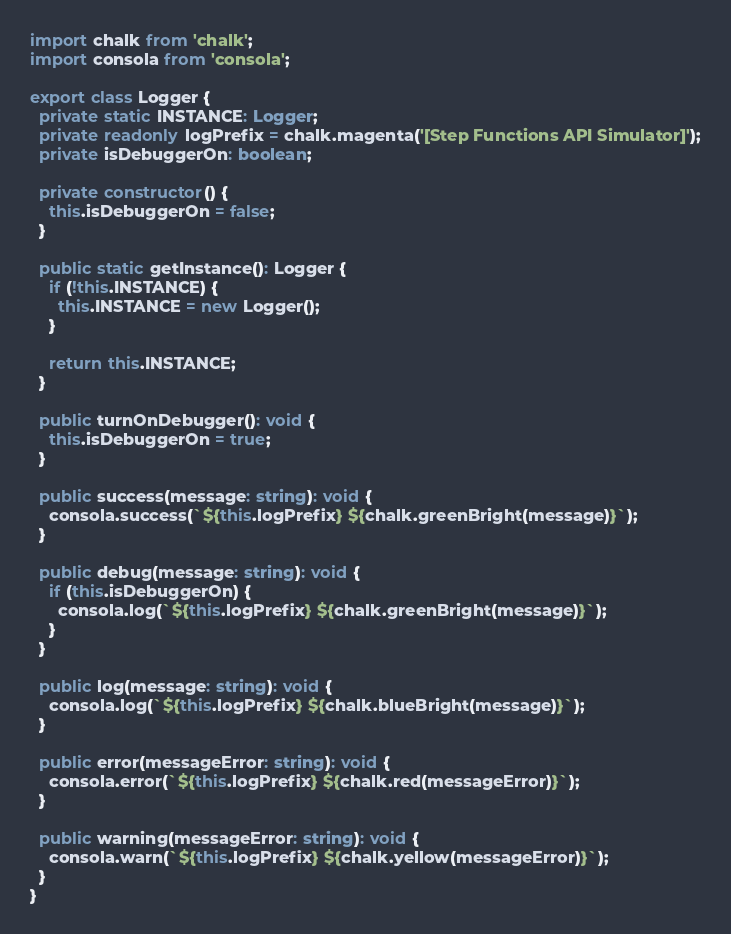<code> <loc_0><loc_0><loc_500><loc_500><_TypeScript_>import chalk from 'chalk';
import consola from 'consola';

export class Logger {
  private static INSTANCE: Logger;
  private readonly logPrefix = chalk.magenta('[Step Functions API Simulator]');
  private isDebuggerOn: boolean;

  private constructor() {
    this.isDebuggerOn = false;
  }

  public static getInstance(): Logger {
    if (!this.INSTANCE) {
      this.INSTANCE = new Logger();
    }

    return this.INSTANCE;
  }

  public turnOnDebugger(): void {
    this.isDebuggerOn = true;
  }

  public success(message: string): void {
    consola.success(`${this.logPrefix} ${chalk.greenBright(message)}`);
  }

  public debug(message: string): void {
    if (this.isDebuggerOn) {
      consola.log(`${this.logPrefix} ${chalk.greenBright(message)}`);
    }
  }

  public log(message: string): void {
    consola.log(`${this.logPrefix} ${chalk.blueBright(message)}`);
  }

  public error(messageError: string): void {
    consola.error(`${this.logPrefix} ${chalk.red(messageError)}`);
  }

  public warning(messageError: string): void {
    consola.warn(`${this.logPrefix} ${chalk.yellow(messageError)}`);
  }
}
</code> 